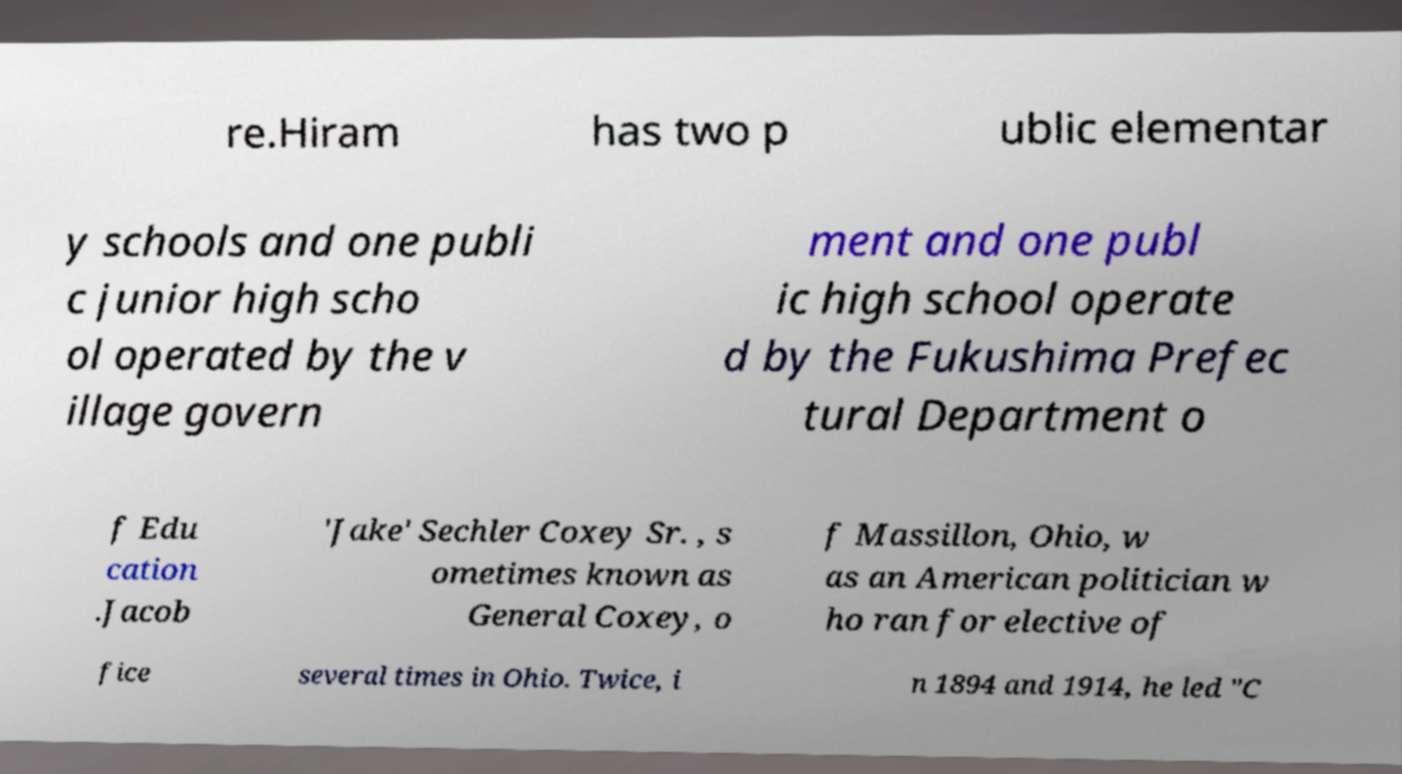Could you extract and type out the text from this image? re.Hiram has two p ublic elementar y schools and one publi c junior high scho ol operated by the v illage govern ment and one publ ic high school operate d by the Fukushima Prefec tural Department o f Edu cation .Jacob 'Jake' Sechler Coxey Sr. , s ometimes known as General Coxey, o f Massillon, Ohio, w as an American politician w ho ran for elective of fice several times in Ohio. Twice, i n 1894 and 1914, he led "C 